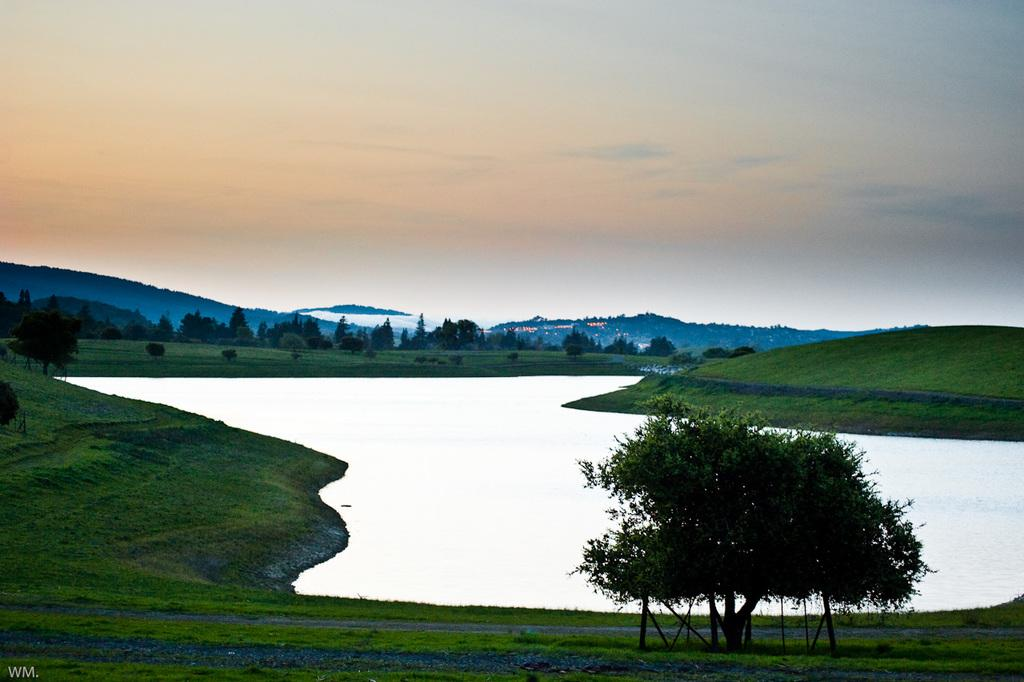What type of terrain is visible in the foreground of the image? There is a grassland and water visible in the foreground of the image. What objects can be seen in the foreground of the image? There is a tree and water visible in the foreground of the image. What type of vegetation is present in the background of the image? There are trees and a grassland visible in the background of the image. What geographical features can be seen in the background of the image? There are mountains visible in the background of the image. What else can be seen in the background of the image? There are lights and the sky visible in the background of the image. Where is the volleyball court located in the image? There is no volleyball court present in the image. What type of animal is playing with the ray in the image? There is no ray or animal playing with it in the image. 